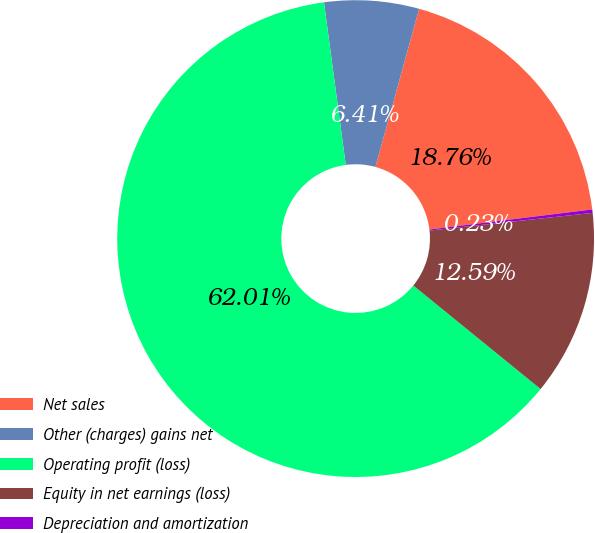<chart> <loc_0><loc_0><loc_500><loc_500><pie_chart><fcel>Net sales<fcel>Other (charges) gains net<fcel>Operating profit (loss)<fcel>Equity in net earnings (loss)<fcel>Depreciation and amortization<nl><fcel>18.76%<fcel>6.41%<fcel>62.01%<fcel>12.59%<fcel>0.23%<nl></chart> 